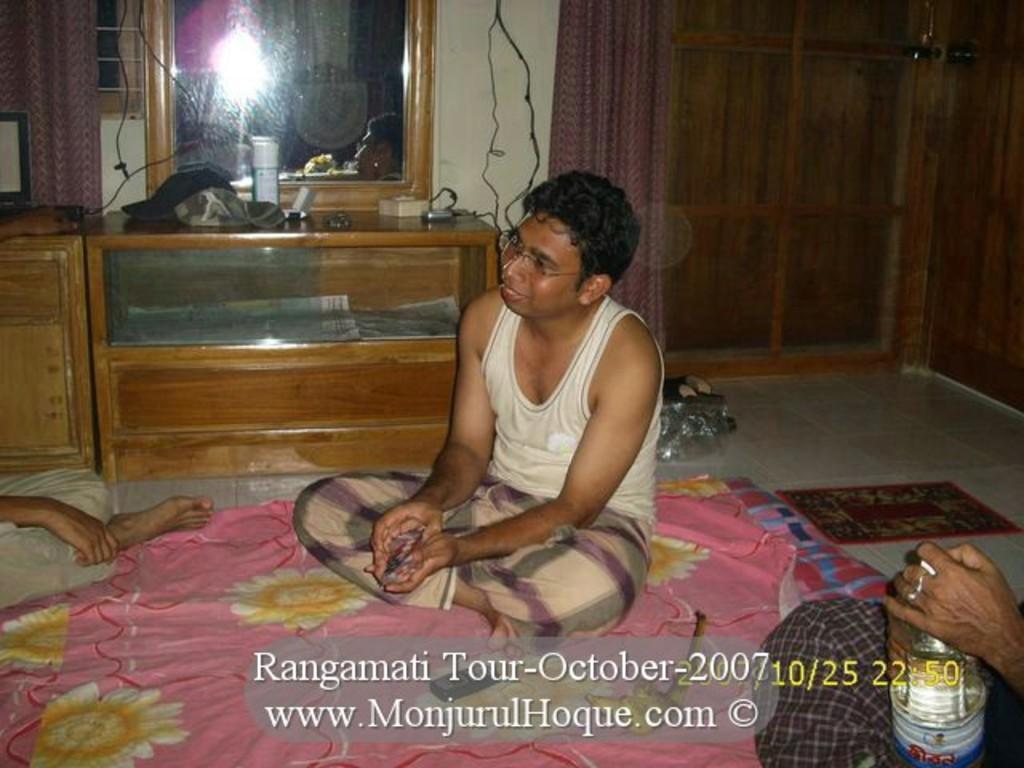How would you summarize this image in a sentence or two? In this picture there is a Indian man sitting on the ground with colorful bed sheet. Behind there is a mirror table and purple color curtains. Beside there is a wooden door. In the front side there is a man sitting and holding the bottle. On the front bottom side there is a small quote and dates are mentioned. 